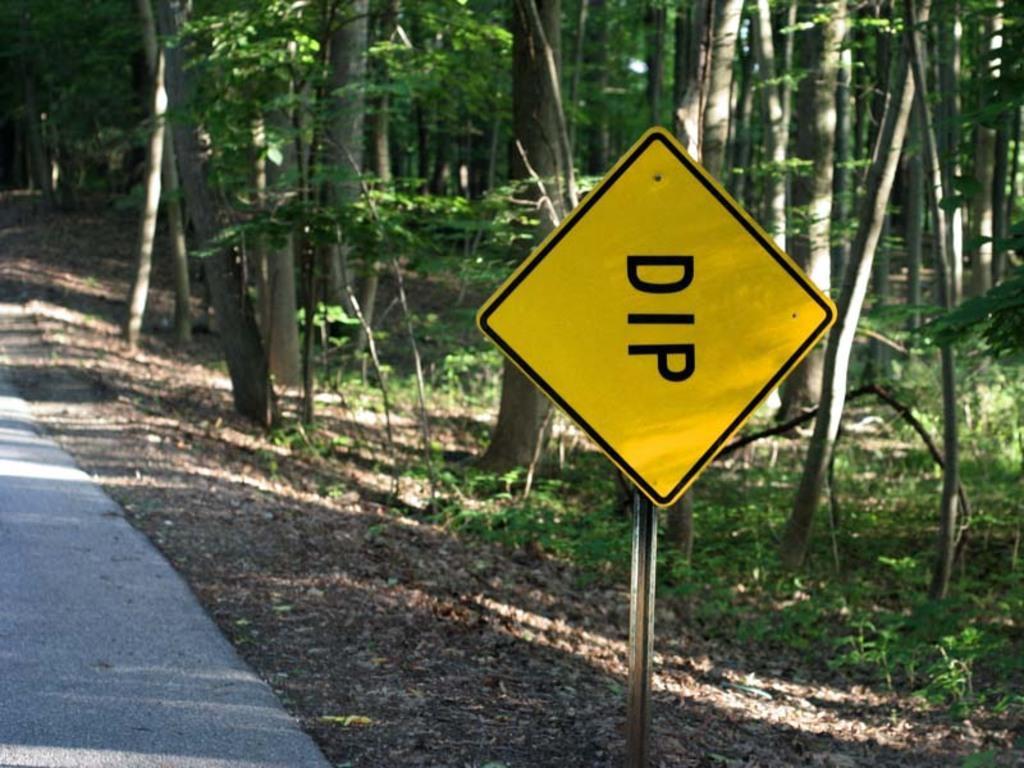What is the main object in the center of the image? There is a board in the center of the image. What can be seen in the background of the image? There are trees in the background of the image. What is located at the bottom of the image? There is a road at the bottom of the image. What type of surface is visible in the image? There is ground visible in the image. What type of leather is used to make the crib in the image? There is no crib present in the image, so it is not possible to determine the type of leather used. 